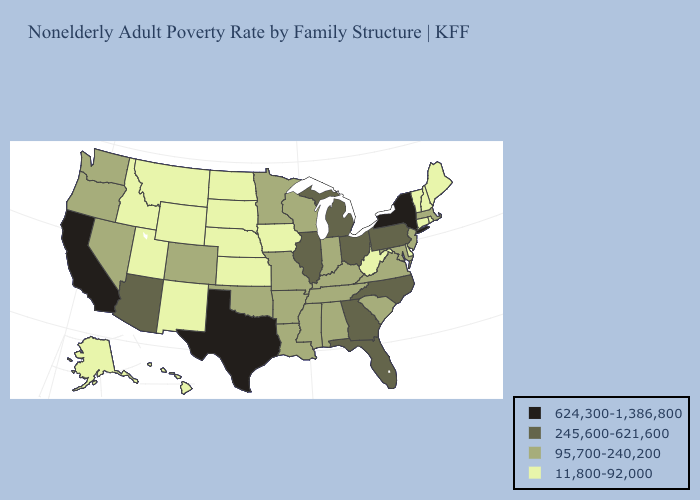What is the lowest value in the West?
Concise answer only. 11,800-92,000. Does Arizona have the highest value in the USA?
Concise answer only. No. Name the states that have a value in the range 245,600-621,600?
Be succinct. Arizona, Florida, Georgia, Illinois, Michigan, North Carolina, Ohio, Pennsylvania. Does Florida have a lower value than New York?
Be succinct. Yes. Does Illinois have a lower value than New York?
Quick response, please. Yes. Name the states that have a value in the range 11,800-92,000?
Quick response, please. Alaska, Connecticut, Delaware, Hawaii, Idaho, Iowa, Kansas, Maine, Montana, Nebraska, New Hampshire, New Mexico, North Dakota, Rhode Island, South Dakota, Utah, Vermont, West Virginia, Wyoming. What is the highest value in the West ?
Concise answer only. 624,300-1,386,800. Name the states that have a value in the range 95,700-240,200?
Quick response, please. Alabama, Arkansas, Colorado, Indiana, Kentucky, Louisiana, Maryland, Massachusetts, Minnesota, Mississippi, Missouri, Nevada, New Jersey, Oklahoma, Oregon, South Carolina, Tennessee, Virginia, Washington, Wisconsin. What is the value of Missouri?
Give a very brief answer. 95,700-240,200. Name the states that have a value in the range 11,800-92,000?
Concise answer only. Alaska, Connecticut, Delaware, Hawaii, Idaho, Iowa, Kansas, Maine, Montana, Nebraska, New Hampshire, New Mexico, North Dakota, Rhode Island, South Dakota, Utah, Vermont, West Virginia, Wyoming. What is the value of Wyoming?
Concise answer only. 11,800-92,000. Does New Mexico have the same value as Kansas?
Answer briefly. Yes. What is the value of Tennessee?
Concise answer only. 95,700-240,200. What is the value of Delaware?
Be succinct. 11,800-92,000. Among the states that border Washington , which have the lowest value?
Quick response, please. Idaho. 